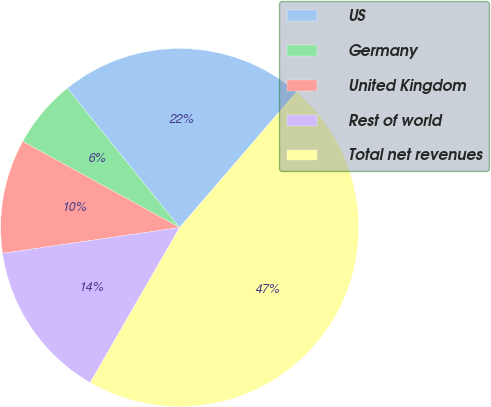Convert chart. <chart><loc_0><loc_0><loc_500><loc_500><pie_chart><fcel>US<fcel>Germany<fcel>United Kingdom<fcel>Rest of world<fcel>Total net revenues<nl><fcel>22.12%<fcel>6.21%<fcel>10.29%<fcel>14.37%<fcel>47.01%<nl></chart> 